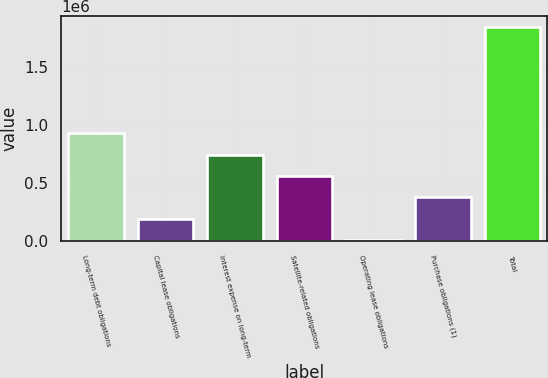Convert chart. <chart><loc_0><loc_0><loc_500><loc_500><bar_chart><fcel>Long-term debt obligations<fcel>Capital lease obligations<fcel>Interest expense on long-term<fcel>Satellite-related obligations<fcel>Operating lease obligations<fcel>Purchase obligations (1)<fcel>Total<nl><fcel>929054<fcel>192644<fcel>744951<fcel>560849<fcel>8541<fcel>376746<fcel>1.84957e+06<nl></chart> 